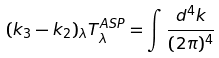<formula> <loc_0><loc_0><loc_500><loc_500>( k _ { 3 } - k _ { 2 } ) _ { \lambda } T _ { \lambda } ^ { A S P } = \int \frac { d ^ { 4 } k } { ( 2 \pi ) ^ { 4 } }</formula> 